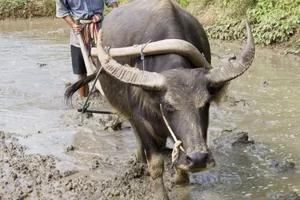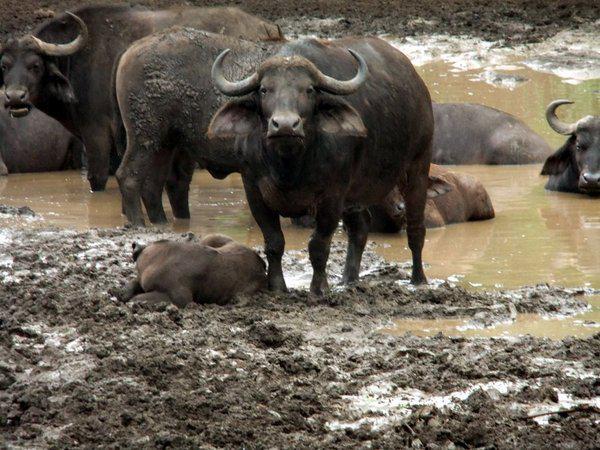The first image is the image on the left, the second image is the image on the right. Examine the images to the left and right. Is the description "The buffalo in the right image has its head down in the grass." accurate? Answer yes or no. No. The first image is the image on the left, the second image is the image on the right. Assess this claim about the two images: "An image shows exactly one water buffalo standing in wet area.". Correct or not? Answer yes or no. Yes. 